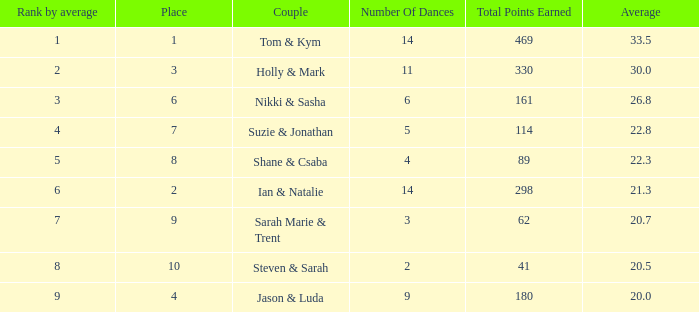3? 1.0. 